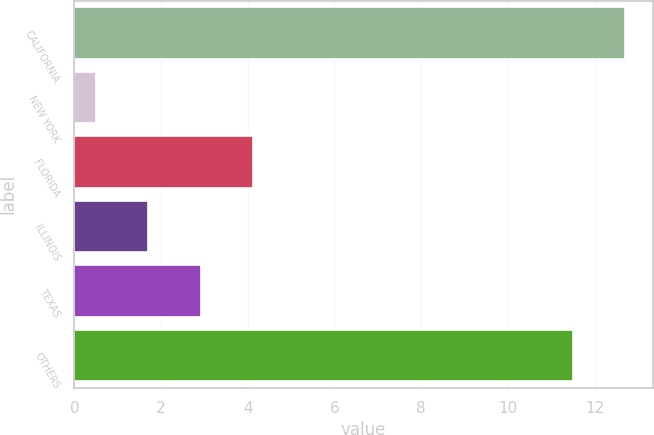<chart> <loc_0><loc_0><loc_500><loc_500><bar_chart><fcel>CALIFORNIA<fcel>NEW YORK<fcel>FLORIDA<fcel>ILLINOIS<fcel>TEXAS<fcel>OTHERS<nl><fcel>12.71<fcel>0.5<fcel>4.13<fcel>1.71<fcel>2.92<fcel>11.5<nl></chart> 